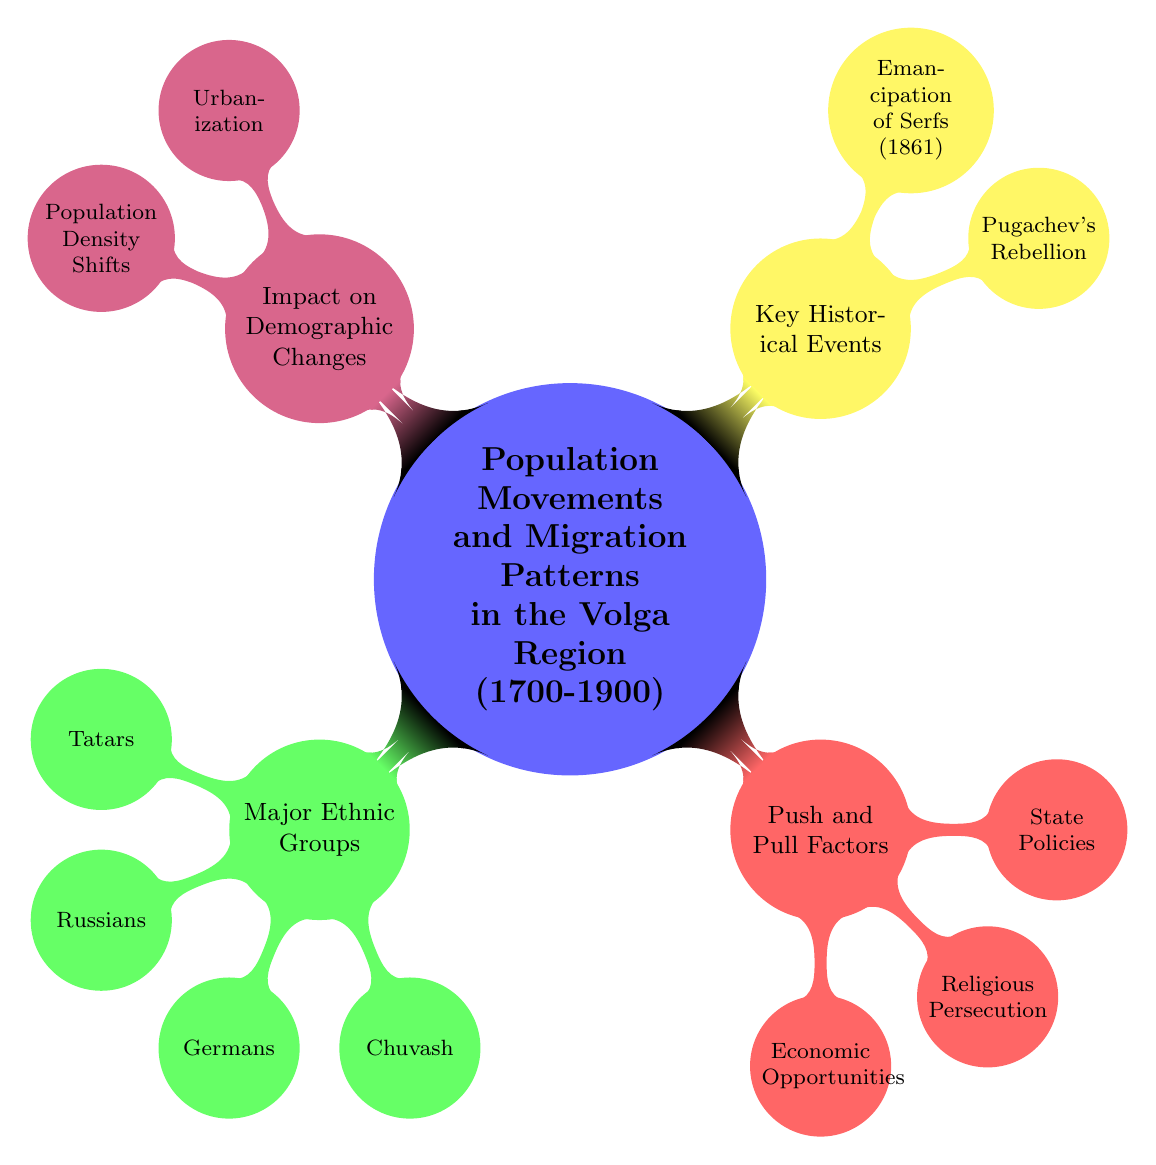What are the major ethnic groups listed in the diagram? The diagram explicitly identifies four major ethnic groups: Tatars, Russians, Germans, and Chuvash under the "Major Ethnic Groups" node.
Answer: Tatars, Russians, Germans, Chuvash How many push and pull factors are identified? The diagram lists three push and pull factors: Economic Opportunities, Religious Persecution, and State Policies, under the "Push and Pull Factors" node.
Answer: 3 What event is shown to have disrupted migration? The diagram indicates that Pugachev's Rebellion had an impact on population through migration disruptions, as detailed in the "Key Historical Events" section.
Answer: Pugachev's Rebellion Which ethnic group has roots in Central Asia? The diagram notes that the Tatars have origins in Central Asia in the "Major Ethnic Groups" section.
Answer: Tatars What factor encouraged migration after the emancipation of serfs? The diagram states that resettlement programs encouraged migration following the Emancipation of Serfs in 1861, found in the "Key Historical Events" section.
Answer: Resettlement Programs How many nodes are in the "Impact on Demographic Changes" section? The section "Impact on Demographic Changes" contains two nodes: Urbanization and Population Density Shifts, thus totaling two nodes.
Answer: 2 What caused rural to urban migration according to the diagram? The diagram suggests that labor demand in cities drove rural to urban migration, indicated under the "Population Density Shifts" node.
Answer: Labor Demand in Cities Which German settlements are highlighted in the diagram? The "Key Settlements" identified under the Germans include Saratov and Samara, as mentioned in the "Major Ethnic Groups" section.
Answer: Saratov, Samara 